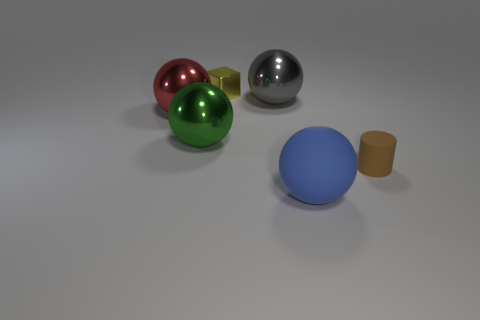Subtract all metallic balls. How many balls are left? 1 Add 4 big green shiny things. How many objects exist? 10 Subtract all blue balls. How many balls are left? 3 Subtract all red metallic objects. Subtract all large blue things. How many objects are left? 4 Add 4 big blue matte objects. How many big blue matte objects are left? 5 Add 4 big red matte cylinders. How many big red matte cylinders exist? 4 Subtract 1 yellow blocks. How many objects are left? 5 Subtract all cylinders. How many objects are left? 5 Subtract all green cylinders. Subtract all cyan cubes. How many cylinders are left? 1 Subtract all cyan cubes. How many gray cylinders are left? 0 